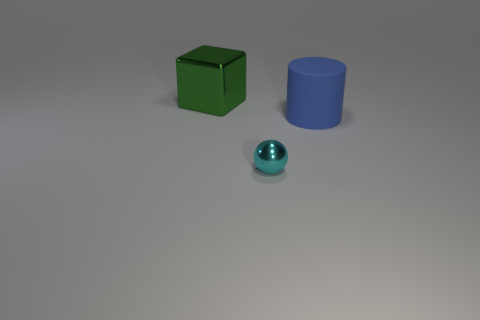Add 1 large things. How many objects exist? 4 Subtract all spheres. How many objects are left? 2 Subtract all green spheres. Subtract all yellow blocks. How many spheres are left? 1 Subtract 0 brown balls. How many objects are left? 3 Subtract all green objects. Subtract all tiny matte objects. How many objects are left? 2 Add 1 cylinders. How many cylinders are left? 2 Add 2 red rubber balls. How many red rubber balls exist? 2 